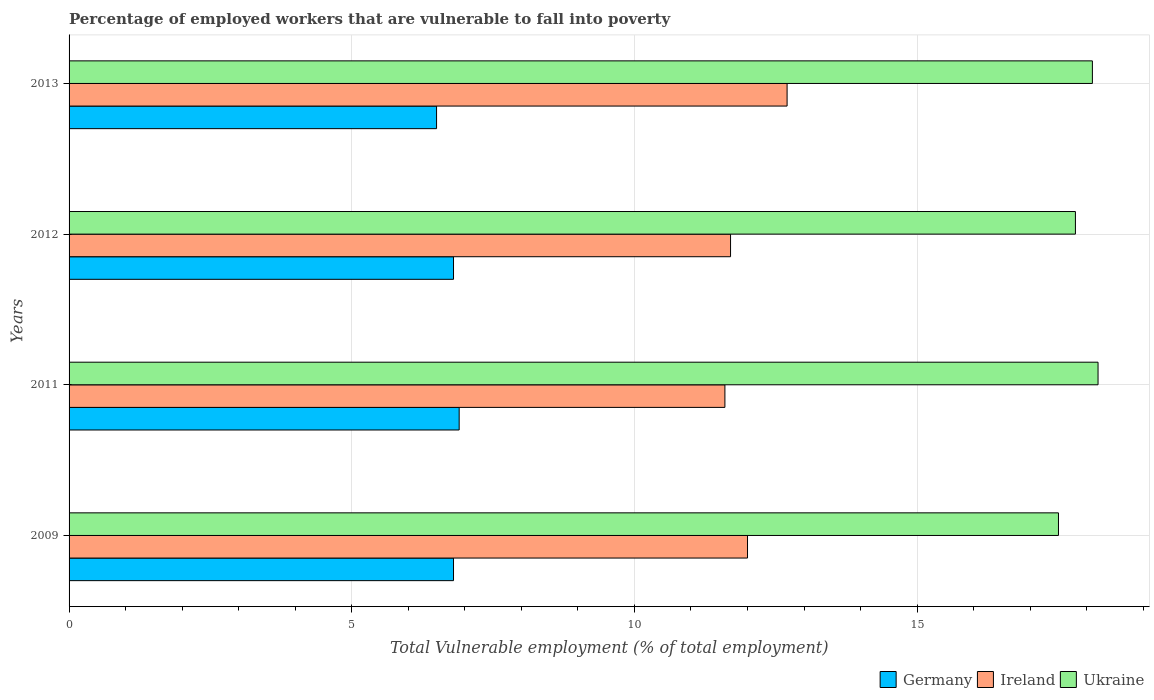How many different coloured bars are there?
Keep it short and to the point. 3. How many groups of bars are there?
Provide a short and direct response. 4. In how many cases, is the number of bars for a given year not equal to the number of legend labels?
Keep it short and to the point. 0. What is the percentage of employed workers who are vulnerable to fall into poverty in Ukraine in 2011?
Provide a short and direct response. 18.2. Across all years, what is the maximum percentage of employed workers who are vulnerable to fall into poverty in Ireland?
Your answer should be very brief. 12.7. Across all years, what is the minimum percentage of employed workers who are vulnerable to fall into poverty in Ireland?
Keep it short and to the point. 11.6. What is the total percentage of employed workers who are vulnerable to fall into poverty in Ukraine in the graph?
Give a very brief answer. 71.6. What is the difference between the percentage of employed workers who are vulnerable to fall into poverty in Germany in 2011 and that in 2012?
Make the answer very short. 0.1. What is the difference between the percentage of employed workers who are vulnerable to fall into poverty in Ireland in 2011 and the percentage of employed workers who are vulnerable to fall into poverty in Ukraine in 2013?
Make the answer very short. -6.5. What is the average percentage of employed workers who are vulnerable to fall into poverty in Germany per year?
Your answer should be compact. 6.75. In the year 2011, what is the difference between the percentage of employed workers who are vulnerable to fall into poverty in Germany and percentage of employed workers who are vulnerable to fall into poverty in Ukraine?
Give a very brief answer. -11.3. What is the ratio of the percentage of employed workers who are vulnerable to fall into poverty in Germany in 2009 to that in 2012?
Offer a very short reply. 1. What is the difference between the highest and the second highest percentage of employed workers who are vulnerable to fall into poverty in Ireland?
Ensure brevity in your answer.  0.7. What is the difference between the highest and the lowest percentage of employed workers who are vulnerable to fall into poverty in Ireland?
Provide a short and direct response. 1.1. In how many years, is the percentage of employed workers who are vulnerable to fall into poverty in Germany greater than the average percentage of employed workers who are vulnerable to fall into poverty in Germany taken over all years?
Your response must be concise. 3. Is it the case that in every year, the sum of the percentage of employed workers who are vulnerable to fall into poverty in Ukraine and percentage of employed workers who are vulnerable to fall into poverty in Germany is greater than the percentage of employed workers who are vulnerable to fall into poverty in Ireland?
Ensure brevity in your answer.  Yes. Are all the bars in the graph horizontal?
Your answer should be compact. Yes. Does the graph contain any zero values?
Your answer should be compact. No. Where does the legend appear in the graph?
Your answer should be compact. Bottom right. How many legend labels are there?
Make the answer very short. 3. What is the title of the graph?
Provide a short and direct response. Percentage of employed workers that are vulnerable to fall into poverty. Does "Europe(all income levels)" appear as one of the legend labels in the graph?
Offer a terse response. No. What is the label or title of the X-axis?
Your answer should be compact. Total Vulnerable employment (% of total employment). What is the Total Vulnerable employment (% of total employment) of Germany in 2009?
Provide a short and direct response. 6.8. What is the Total Vulnerable employment (% of total employment) of Germany in 2011?
Offer a very short reply. 6.9. What is the Total Vulnerable employment (% of total employment) of Ireland in 2011?
Ensure brevity in your answer.  11.6. What is the Total Vulnerable employment (% of total employment) of Ukraine in 2011?
Your response must be concise. 18.2. What is the Total Vulnerable employment (% of total employment) of Germany in 2012?
Your answer should be compact. 6.8. What is the Total Vulnerable employment (% of total employment) in Ireland in 2012?
Keep it short and to the point. 11.7. What is the Total Vulnerable employment (% of total employment) of Ukraine in 2012?
Your answer should be compact. 17.8. What is the Total Vulnerable employment (% of total employment) of Ireland in 2013?
Provide a succinct answer. 12.7. What is the Total Vulnerable employment (% of total employment) in Ukraine in 2013?
Your answer should be very brief. 18.1. Across all years, what is the maximum Total Vulnerable employment (% of total employment) in Germany?
Keep it short and to the point. 6.9. Across all years, what is the maximum Total Vulnerable employment (% of total employment) of Ireland?
Keep it short and to the point. 12.7. Across all years, what is the maximum Total Vulnerable employment (% of total employment) in Ukraine?
Your answer should be compact. 18.2. Across all years, what is the minimum Total Vulnerable employment (% of total employment) of Germany?
Your answer should be compact. 6.5. Across all years, what is the minimum Total Vulnerable employment (% of total employment) of Ireland?
Keep it short and to the point. 11.6. Across all years, what is the minimum Total Vulnerable employment (% of total employment) of Ukraine?
Make the answer very short. 17.5. What is the total Total Vulnerable employment (% of total employment) of Germany in the graph?
Offer a very short reply. 27. What is the total Total Vulnerable employment (% of total employment) of Ukraine in the graph?
Your response must be concise. 71.6. What is the difference between the Total Vulnerable employment (% of total employment) of Ireland in 2009 and that in 2011?
Make the answer very short. 0.4. What is the difference between the Total Vulnerable employment (% of total employment) in Ukraine in 2009 and that in 2011?
Your response must be concise. -0.7. What is the difference between the Total Vulnerable employment (% of total employment) in Germany in 2009 and that in 2012?
Keep it short and to the point. 0. What is the difference between the Total Vulnerable employment (% of total employment) of Ireland in 2009 and that in 2012?
Offer a terse response. 0.3. What is the difference between the Total Vulnerable employment (% of total employment) in Germany in 2009 and that in 2013?
Provide a succinct answer. 0.3. What is the difference between the Total Vulnerable employment (% of total employment) of Ireland in 2009 and that in 2013?
Ensure brevity in your answer.  -0.7. What is the difference between the Total Vulnerable employment (% of total employment) in Ukraine in 2009 and that in 2013?
Your response must be concise. -0.6. What is the difference between the Total Vulnerable employment (% of total employment) in Germany in 2011 and that in 2012?
Your answer should be very brief. 0.1. What is the difference between the Total Vulnerable employment (% of total employment) of Germany in 2011 and that in 2013?
Keep it short and to the point. 0.4. What is the difference between the Total Vulnerable employment (% of total employment) in Germany in 2012 and that in 2013?
Your response must be concise. 0.3. What is the difference between the Total Vulnerable employment (% of total employment) in Ireland in 2012 and that in 2013?
Make the answer very short. -1. What is the difference between the Total Vulnerable employment (% of total employment) of Ukraine in 2012 and that in 2013?
Provide a short and direct response. -0.3. What is the difference between the Total Vulnerable employment (% of total employment) of Germany in 2009 and the Total Vulnerable employment (% of total employment) of Ireland in 2011?
Your response must be concise. -4.8. What is the difference between the Total Vulnerable employment (% of total employment) in Ireland in 2009 and the Total Vulnerable employment (% of total employment) in Ukraine in 2011?
Keep it short and to the point. -6.2. What is the difference between the Total Vulnerable employment (% of total employment) in Germany in 2009 and the Total Vulnerable employment (% of total employment) in Ireland in 2012?
Provide a short and direct response. -4.9. What is the difference between the Total Vulnerable employment (% of total employment) of Germany in 2009 and the Total Vulnerable employment (% of total employment) of Ukraine in 2012?
Give a very brief answer. -11. What is the difference between the Total Vulnerable employment (% of total employment) of Ireland in 2009 and the Total Vulnerable employment (% of total employment) of Ukraine in 2013?
Offer a very short reply. -6.1. What is the difference between the Total Vulnerable employment (% of total employment) in Germany in 2011 and the Total Vulnerable employment (% of total employment) in Ireland in 2013?
Your response must be concise. -5.8. What is the difference between the Total Vulnerable employment (% of total employment) of Germany in 2011 and the Total Vulnerable employment (% of total employment) of Ukraine in 2013?
Keep it short and to the point. -11.2. What is the difference between the Total Vulnerable employment (% of total employment) in Ireland in 2011 and the Total Vulnerable employment (% of total employment) in Ukraine in 2013?
Keep it short and to the point. -6.5. What is the difference between the Total Vulnerable employment (% of total employment) of Germany in 2012 and the Total Vulnerable employment (% of total employment) of Ukraine in 2013?
Offer a very short reply. -11.3. What is the difference between the Total Vulnerable employment (% of total employment) of Ireland in 2012 and the Total Vulnerable employment (% of total employment) of Ukraine in 2013?
Offer a terse response. -6.4. What is the average Total Vulnerable employment (% of total employment) of Germany per year?
Keep it short and to the point. 6.75. What is the average Total Vulnerable employment (% of total employment) in Ireland per year?
Your response must be concise. 12. What is the average Total Vulnerable employment (% of total employment) in Ukraine per year?
Offer a very short reply. 17.9. In the year 2009, what is the difference between the Total Vulnerable employment (% of total employment) in Germany and Total Vulnerable employment (% of total employment) in Ukraine?
Keep it short and to the point. -10.7. In the year 2011, what is the difference between the Total Vulnerable employment (% of total employment) in Germany and Total Vulnerable employment (% of total employment) in Ireland?
Ensure brevity in your answer.  -4.7. In the year 2011, what is the difference between the Total Vulnerable employment (% of total employment) in Ireland and Total Vulnerable employment (% of total employment) in Ukraine?
Give a very brief answer. -6.6. In the year 2012, what is the difference between the Total Vulnerable employment (% of total employment) of Germany and Total Vulnerable employment (% of total employment) of Ireland?
Provide a succinct answer. -4.9. In the year 2013, what is the difference between the Total Vulnerable employment (% of total employment) in Germany and Total Vulnerable employment (% of total employment) in Ireland?
Your answer should be compact. -6.2. In the year 2013, what is the difference between the Total Vulnerable employment (% of total employment) of Ireland and Total Vulnerable employment (% of total employment) of Ukraine?
Offer a very short reply. -5.4. What is the ratio of the Total Vulnerable employment (% of total employment) in Germany in 2009 to that in 2011?
Provide a short and direct response. 0.99. What is the ratio of the Total Vulnerable employment (% of total employment) in Ireland in 2009 to that in 2011?
Provide a succinct answer. 1.03. What is the ratio of the Total Vulnerable employment (% of total employment) in Ukraine in 2009 to that in 2011?
Your answer should be very brief. 0.96. What is the ratio of the Total Vulnerable employment (% of total employment) of Germany in 2009 to that in 2012?
Your answer should be very brief. 1. What is the ratio of the Total Vulnerable employment (% of total employment) of Ireland in 2009 to that in 2012?
Give a very brief answer. 1.03. What is the ratio of the Total Vulnerable employment (% of total employment) of Ukraine in 2009 to that in 2012?
Ensure brevity in your answer.  0.98. What is the ratio of the Total Vulnerable employment (% of total employment) in Germany in 2009 to that in 2013?
Provide a succinct answer. 1.05. What is the ratio of the Total Vulnerable employment (% of total employment) in Ireland in 2009 to that in 2013?
Ensure brevity in your answer.  0.94. What is the ratio of the Total Vulnerable employment (% of total employment) in Ukraine in 2009 to that in 2013?
Provide a short and direct response. 0.97. What is the ratio of the Total Vulnerable employment (% of total employment) in Germany in 2011 to that in 2012?
Provide a succinct answer. 1.01. What is the ratio of the Total Vulnerable employment (% of total employment) of Ireland in 2011 to that in 2012?
Ensure brevity in your answer.  0.99. What is the ratio of the Total Vulnerable employment (% of total employment) in Ukraine in 2011 to that in 2012?
Your answer should be very brief. 1.02. What is the ratio of the Total Vulnerable employment (% of total employment) of Germany in 2011 to that in 2013?
Your answer should be very brief. 1.06. What is the ratio of the Total Vulnerable employment (% of total employment) of Ireland in 2011 to that in 2013?
Your answer should be very brief. 0.91. What is the ratio of the Total Vulnerable employment (% of total employment) of Ukraine in 2011 to that in 2013?
Make the answer very short. 1.01. What is the ratio of the Total Vulnerable employment (% of total employment) in Germany in 2012 to that in 2013?
Your answer should be very brief. 1.05. What is the ratio of the Total Vulnerable employment (% of total employment) of Ireland in 2012 to that in 2013?
Keep it short and to the point. 0.92. What is the ratio of the Total Vulnerable employment (% of total employment) in Ukraine in 2012 to that in 2013?
Offer a very short reply. 0.98. 